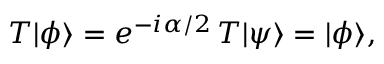Convert formula to latex. <formula><loc_0><loc_0><loc_500><loc_500>T | \phi \rangle = e ^ { - i \alpha / 2 } \, T | \psi \rangle = | \phi \rangle ,</formula> 